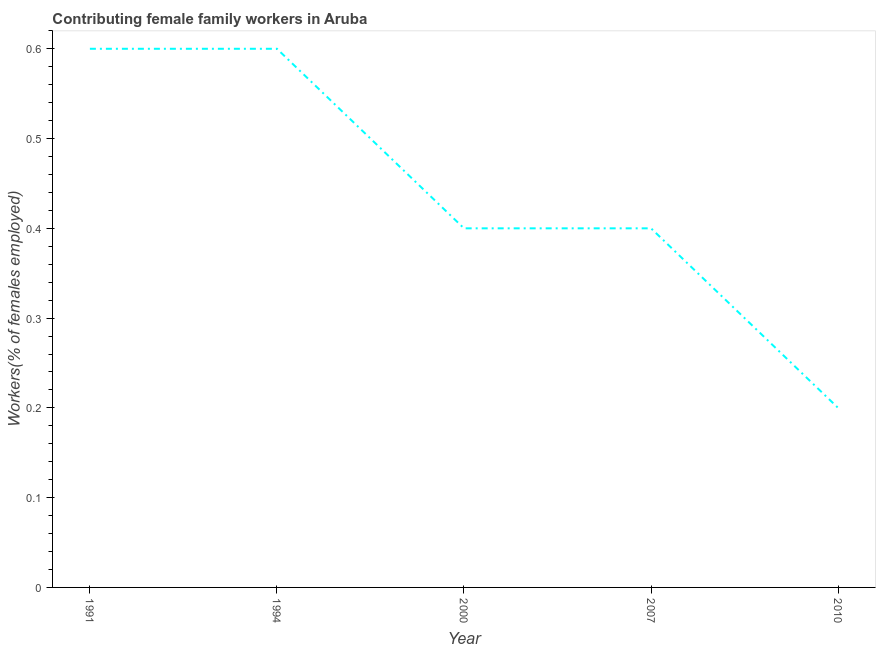What is the contributing female family workers in 2007?
Keep it short and to the point. 0.4. Across all years, what is the maximum contributing female family workers?
Ensure brevity in your answer.  0.6. Across all years, what is the minimum contributing female family workers?
Give a very brief answer. 0.2. What is the sum of the contributing female family workers?
Provide a succinct answer. 2.2. What is the difference between the contributing female family workers in 1994 and 2010?
Give a very brief answer. 0.4. What is the average contributing female family workers per year?
Offer a very short reply. 0.44. What is the median contributing female family workers?
Keep it short and to the point. 0.4. Do a majority of the years between 2010 and 2000 (inclusive) have contributing female family workers greater than 0.6000000000000001 %?
Provide a short and direct response. No. What is the ratio of the contributing female family workers in 2000 to that in 2007?
Offer a very short reply. 1. Is the contributing female family workers in 2007 less than that in 2010?
Your response must be concise. No. Is the difference between the contributing female family workers in 2000 and 2010 greater than the difference between any two years?
Your response must be concise. No. Is the sum of the contributing female family workers in 1991 and 1994 greater than the maximum contributing female family workers across all years?
Give a very brief answer. Yes. What is the difference between the highest and the lowest contributing female family workers?
Provide a short and direct response. 0.4. In how many years, is the contributing female family workers greater than the average contributing female family workers taken over all years?
Ensure brevity in your answer.  2. How many lines are there?
Your answer should be very brief. 1. What is the difference between two consecutive major ticks on the Y-axis?
Your answer should be compact. 0.1. Does the graph contain grids?
Give a very brief answer. No. What is the title of the graph?
Offer a very short reply. Contributing female family workers in Aruba. What is the label or title of the X-axis?
Your response must be concise. Year. What is the label or title of the Y-axis?
Keep it short and to the point. Workers(% of females employed). What is the Workers(% of females employed) of 1991?
Provide a succinct answer. 0.6. What is the Workers(% of females employed) in 1994?
Provide a succinct answer. 0.6. What is the Workers(% of females employed) of 2000?
Keep it short and to the point. 0.4. What is the Workers(% of females employed) of 2007?
Your answer should be compact. 0.4. What is the Workers(% of females employed) in 2010?
Give a very brief answer. 0.2. What is the difference between the Workers(% of females employed) in 1991 and 1994?
Give a very brief answer. 0. What is the difference between the Workers(% of females employed) in 1991 and 2010?
Provide a succinct answer. 0.4. What is the difference between the Workers(% of females employed) in 1994 and 2007?
Offer a very short reply. 0.2. What is the difference between the Workers(% of females employed) in 2000 and 2010?
Make the answer very short. 0.2. What is the ratio of the Workers(% of females employed) in 1991 to that in 1994?
Make the answer very short. 1. What is the ratio of the Workers(% of females employed) in 1991 to that in 2010?
Make the answer very short. 3. What is the ratio of the Workers(% of females employed) in 1994 to that in 2000?
Keep it short and to the point. 1.5. What is the ratio of the Workers(% of females employed) in 1994 to that in 2010?
Your response must be concise. 3. What is the ratio of the Workers(% of females employed) in 2007 to that in 2010?
Ensure brevity in your answer.  2. 